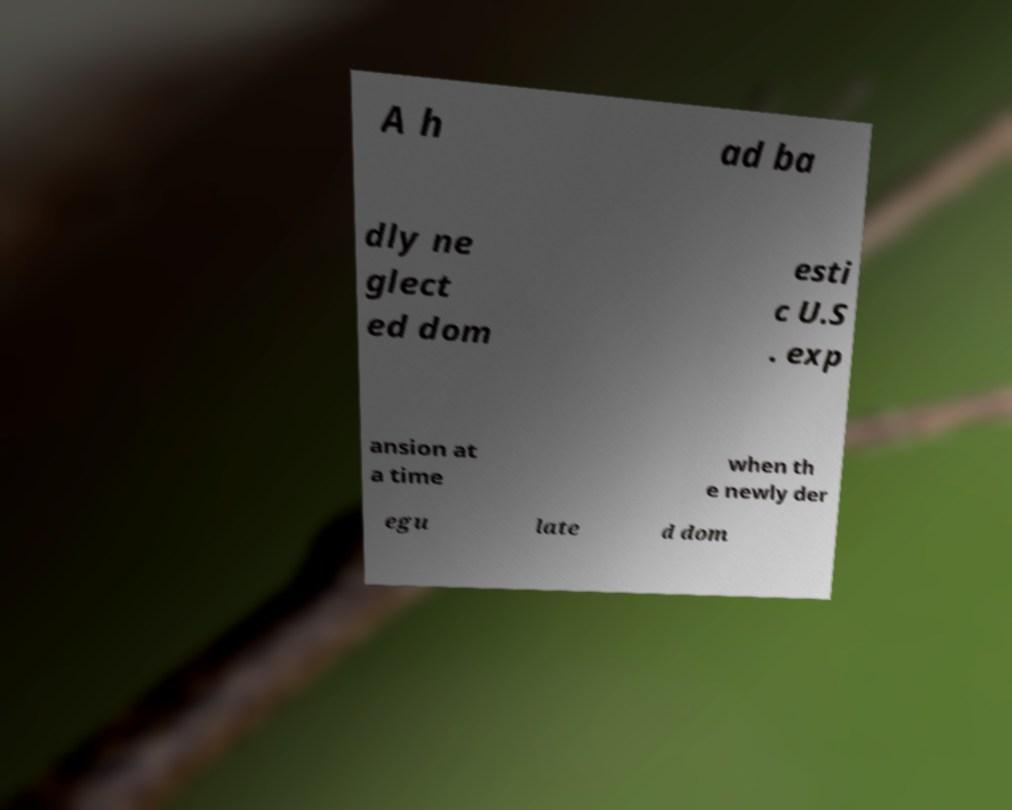Could you assist in decoding the text presented in this image and type it out clearly? A h ad ba dly ne glect ed dom esti c U.S . exp ansion at a time when th e newly der egu late d dom 